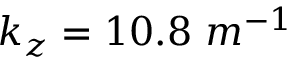<formula> <loc_0><loc_0><loc_500><loc_500>k _ { z } = 1 0 . 8 \ m ^ { - 1 }</formula> 